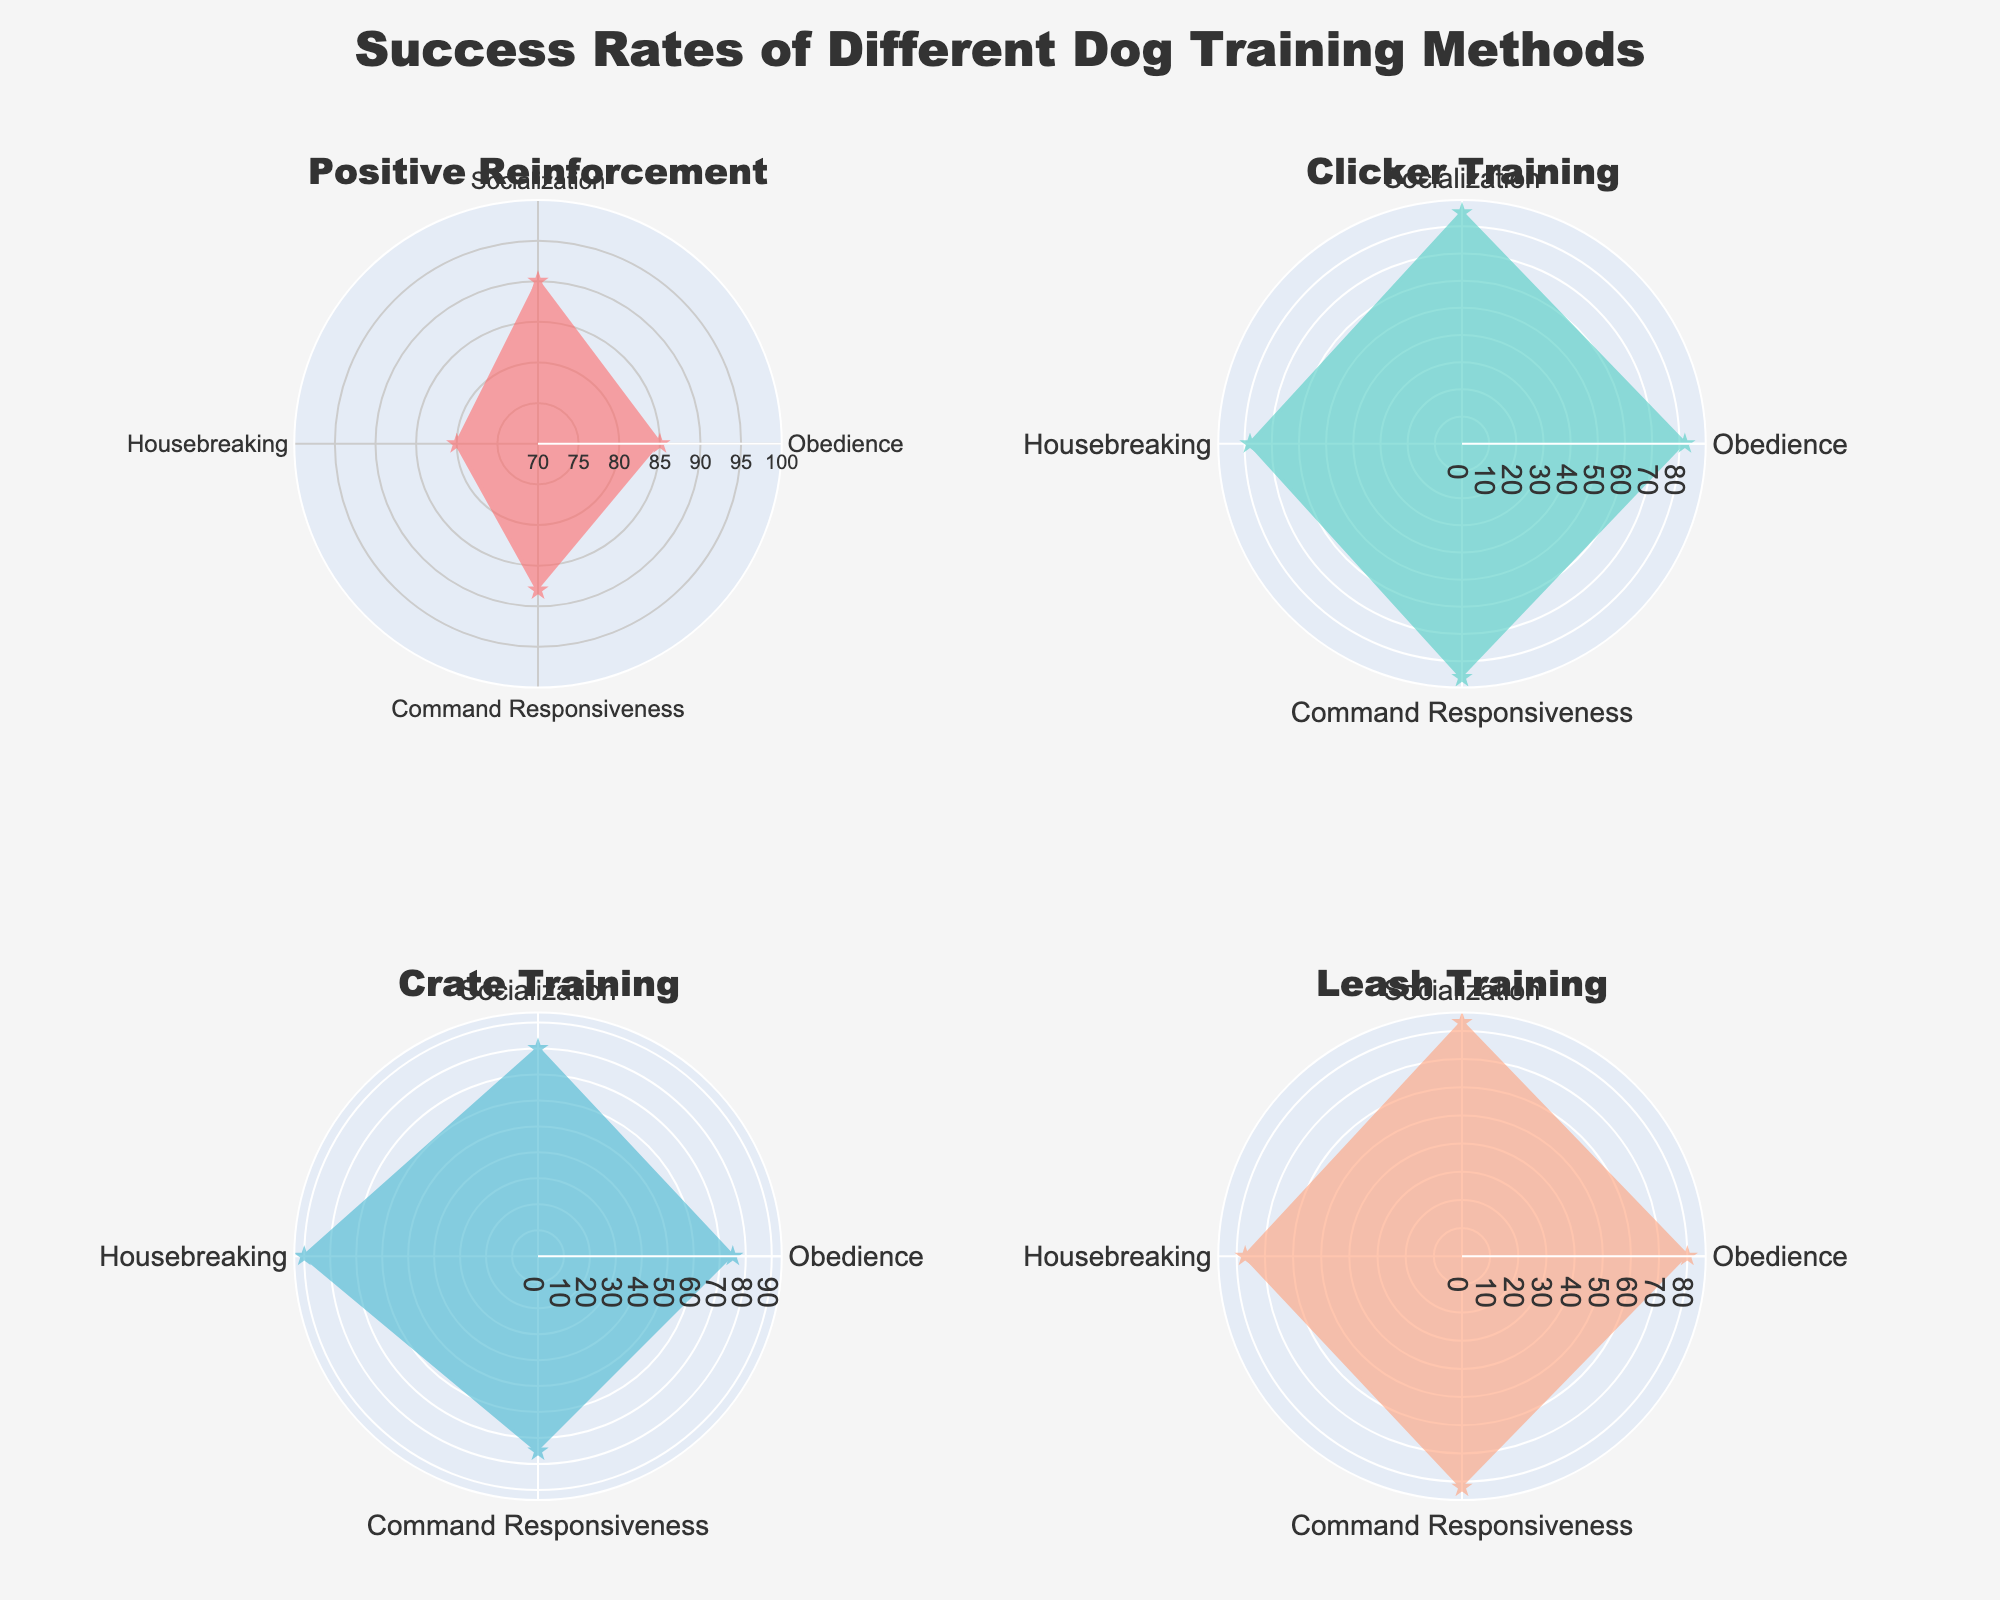What is the title of the figure? The title is usually displayed at the top of the figure. By looking at the center-top area, we can read the title text.
Answer: Success Rates of Different Dog Training Methods What color is used for the Clicker Training method? Each method in the figure is represented by a different color. The Clicker Training method is shown in green.
Answer: Green Which training method has the highest success rate for Housebreaking? By examining the Housebreaking criteria across all subplots, we can identify the method with the highest rate. Crate Training shows a success rate of 90%.
Answer: Crate Training What is the average success rate of all methods for Obedience? Add the success rates for Obedience across all methods and divide by the number of methods: (85 + 82 + 75 + 80) / 4 = 80.5.
Answer: 80.5 Does Positive Reinforcement outperform Clicker Training in Socialization? Compare the success rates for Socialization between Positive Reinforcement and Clicker Training: 90 (Positive Reinforcement) > 85 (Clicker Training).
Answer: Yes Which criteria does Leash Training have the lowest success rate in? By examining the Leash Training subplot, we find the lowest success rate is for Housebreaking with 77%.
Answer: Housebreaking Which training method is the most consistent across the four criteria? Consistency can be judged by the smallest variation in success rates. Positive Reinforcement is the most consistent with rates of 85, 90, 80, and 88, closely clustered around the high 80s.
Answer: Positive Reinforcement How much higher is Crate Training's Housebreaking success rate than its Obedience success rate? Subtract the Obedience success rate from the Housebreaking success rate for Crate Training: 90 - 75 = 15.
Answer: 15 In which training method and criteria is the success rate below 80? Checking all subplots, only Clicker Training for Housebreaking and Crate Training for Obedience have success rates below 80 (78 and 75 respectively).
Answer: Clicker Training (Housebreaking), Crate Training (Obedience) What is the maximum success rate shown in the figure? Scanning through all the success rates presented in the polar charts, the highest rate is 90, appearing in both Positive Reinforcement for Socialization and Crate Training for Housebreaking.
Answer: 90 